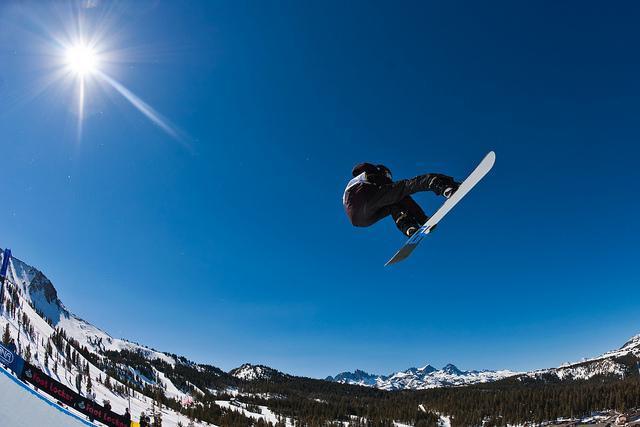How many hands is the snowboarder using to grab his snowboard?
Give a very brief answer. 1. How many kites are flying in the air?
Give a very brief answer. 0. 